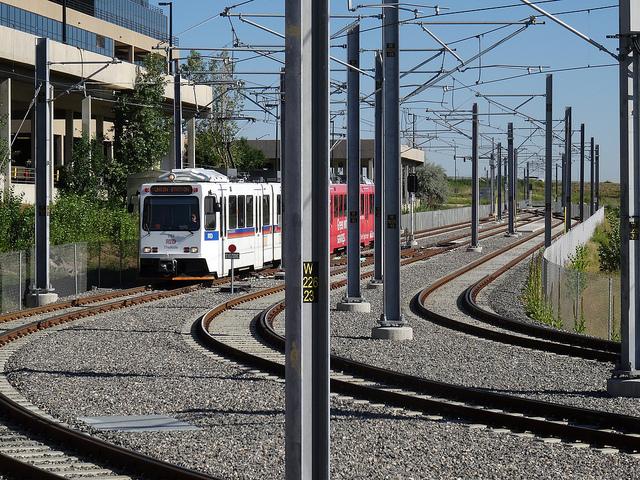How many sets of train tracks are here?
Quick response, please. 3. What color is the first part of the train?
Answer briefly. White. Are the trains two toned?
Keep it brief. Yes. 